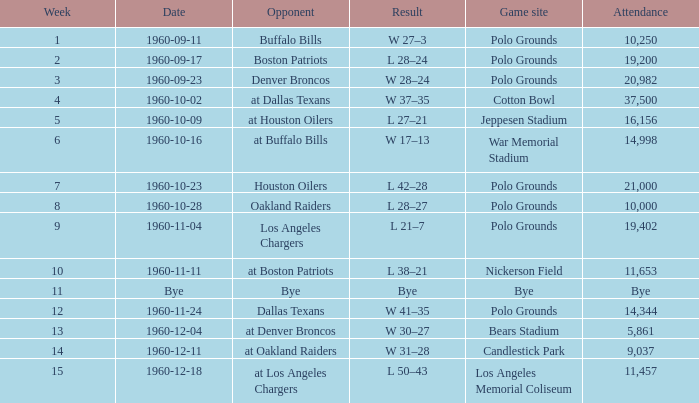What day did they perform at candlestick park? 1960-12-11. 